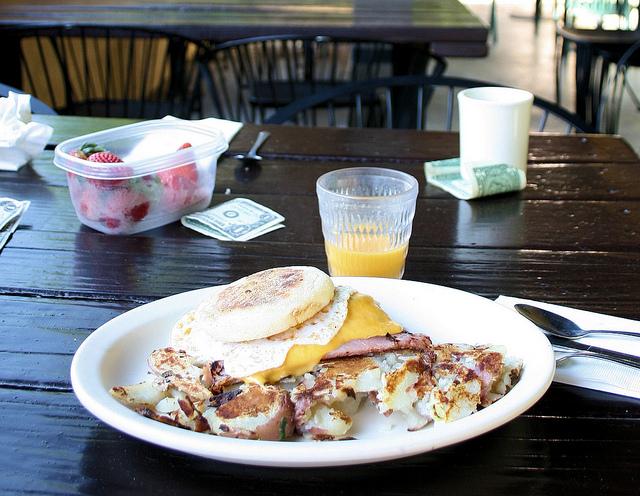What color is the plate?
Give a very brief answer. White. How much money is present?
Answer briefly. 2 dollars. Is there tupperware?
Quick response, please. Yes. 